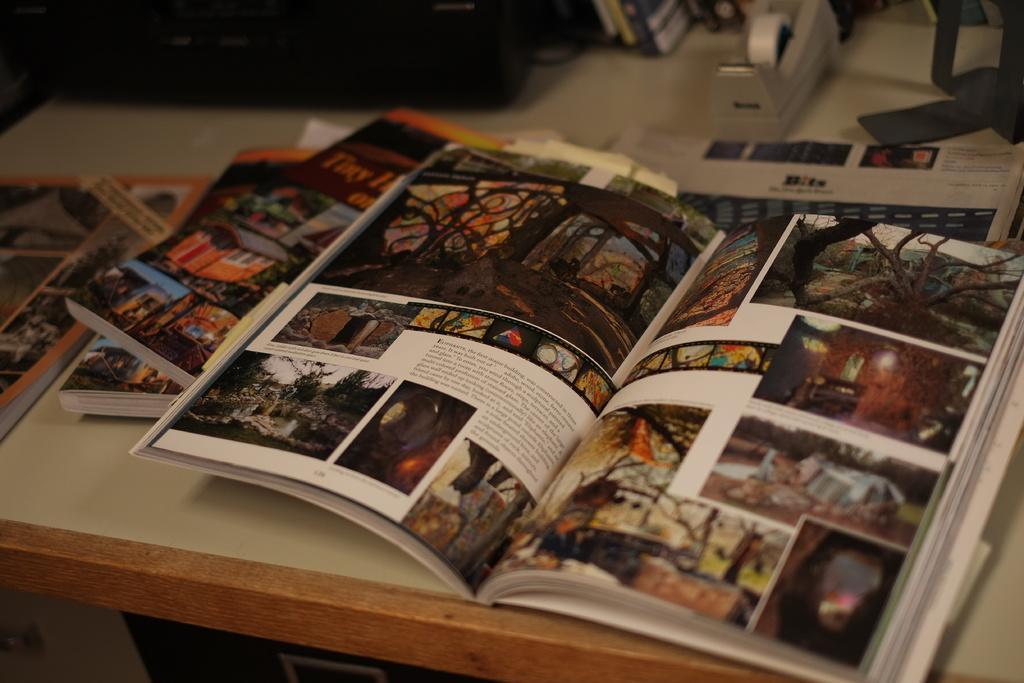Could you give a brief overview of what you see in this image? In the foreground of this picture we can see the pictures of some objects and text printed in the books and the books are placed on the top of the table. In the background there are some objects placed on the table. 